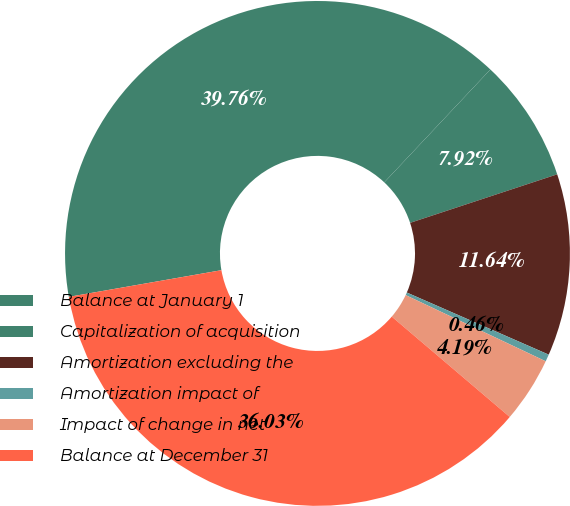Convert chart to OTSL. <chart><loc_0><loc_0><loc_500><loc_500><pie_chart><fcel>Balance at January 1<fcel>Capitalization of acquisition<fcel>Amortization excluding the<fcel>Amortization impact of<fcel>Impact of change in net<fcel>Balance at December 31<nl><fcel>39.76%<fcel>7.92%<fcel>11.64%<fcel>0.46%<fcel>4.19%<fcel>36.03%<nl></chart> 